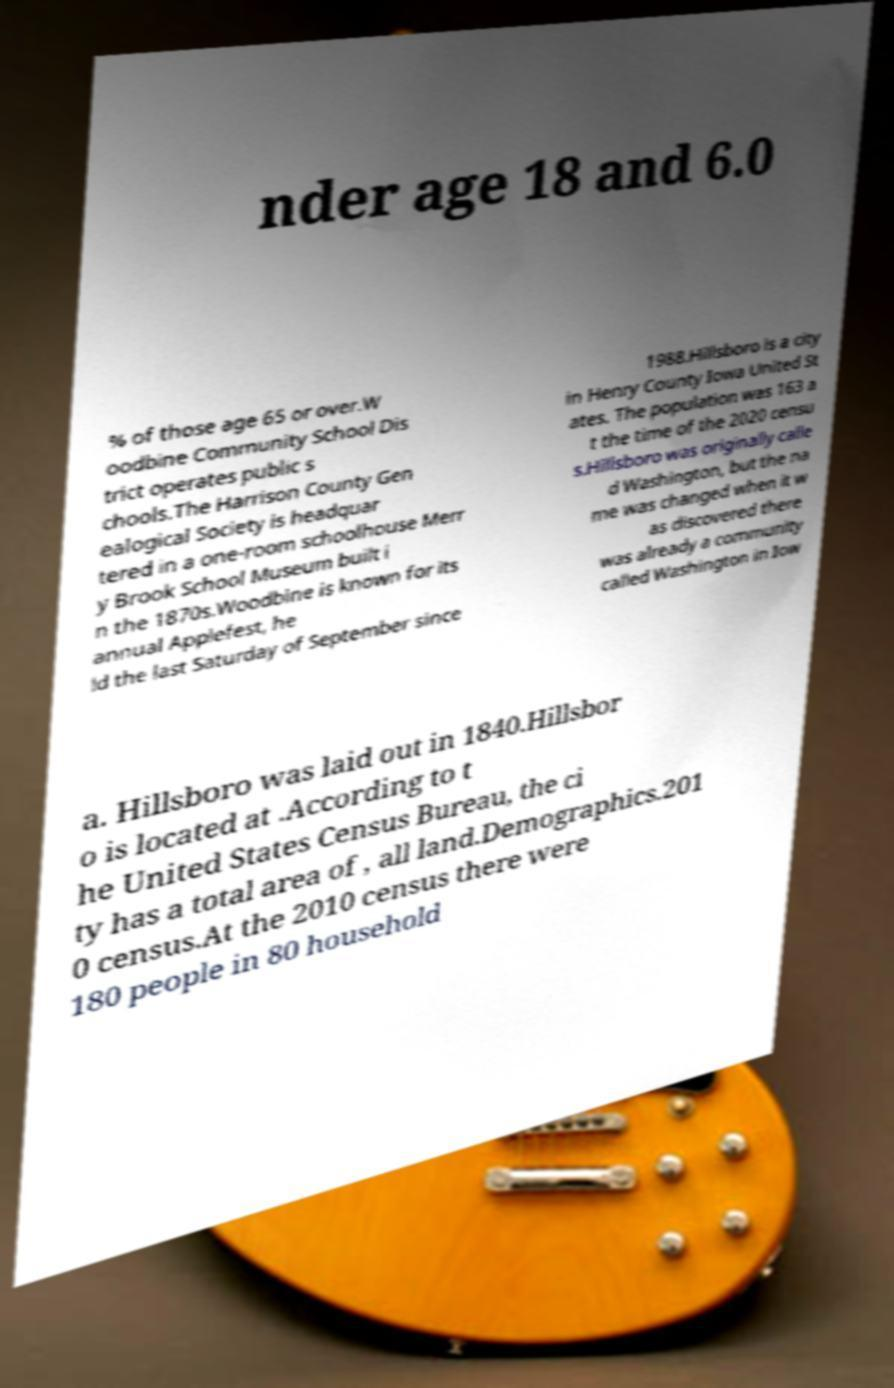I need the written content from this picture converted into text. Can you do that? nder age 18 and 6.0 % of those age 65 or over.W oodbine Community School Dis trict operates public s chools.The Harrison County Gen ealogical Society is headquar tered in a one-room schoolhouse Merr y Brook School Museum built i n the 1870s.Woodbine is known for its annual Applefest, he ld the last Saturday of September since 1988.Hillsboro is a city in Henry County Iowa United St ates. The population was 163 a t the time of the 2020 censu s.Hillsboro was originally calle d Washington, but the na me was changed when it w as discovered there was already a community called Washington in Iow a. Hillsboro was laid out in 1840.Hillsbor o is located at .According to t he United States Census Bureau, the ci ty has a total area of , all land.Demographics.201 0 census.At the 2010 census there were 180 people in 80 household 